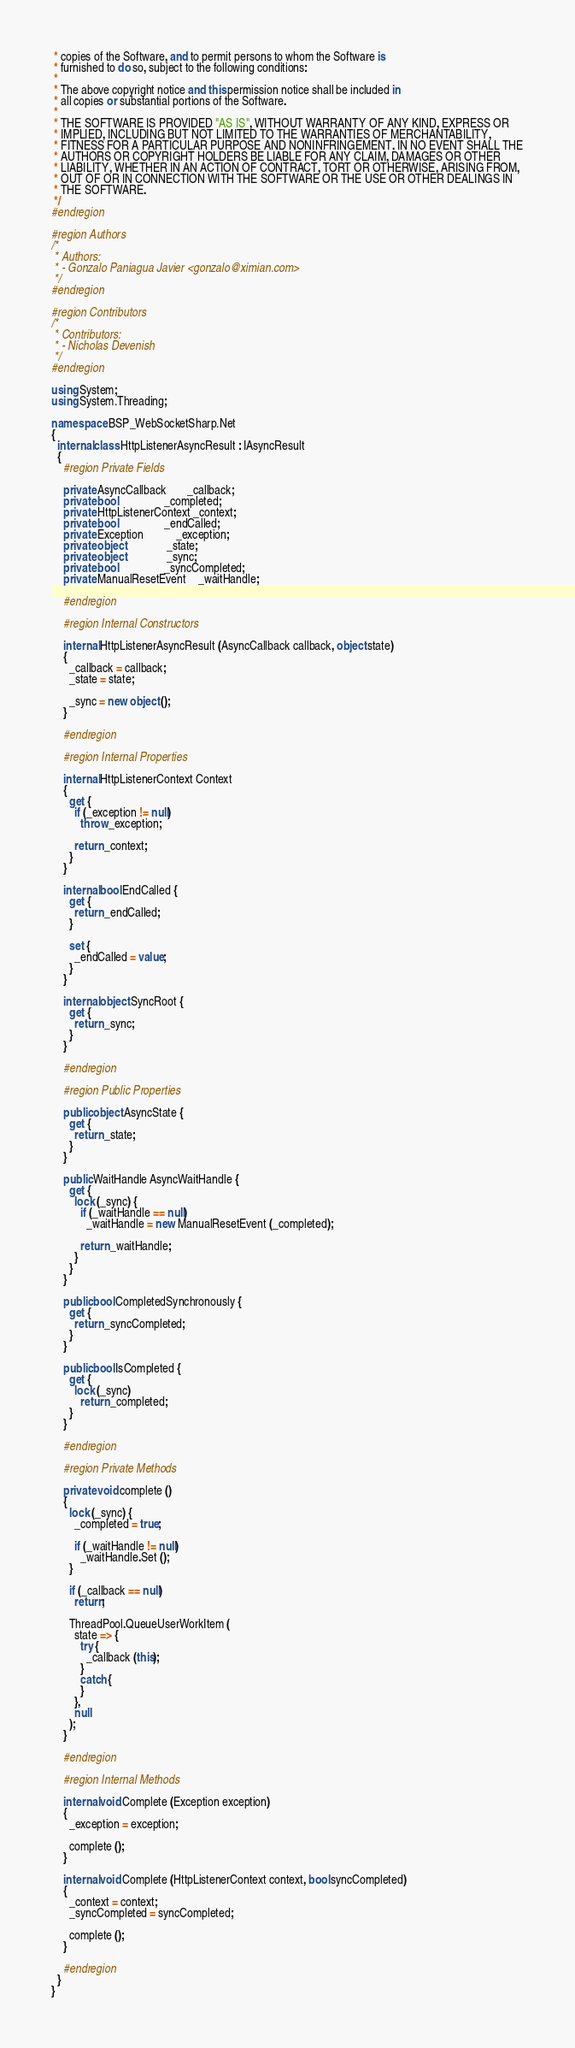<code> <loc_0><loc_0><loc_500><loc_500><_C#_> * copies of the Software, and to permit persons to whom the Software is
 * furnished to do so, subject to the following conditions:
 *
 * The above copyright notice and this permission notice shall be included in
 * all copies or substantial portions of the Software.
 *
 * THE SOFTWARE IS PROVIDED "AS IS", WITHOUT WARRANTY OF ANY KIND, EXPRESS OR
 * IMPLIED, INCLUDING BUT NOT LIMITED TO THE WARRANTIES OF MERCHANTABILITY,
 * FITNESS FOR A PARTICULAR PURPOSE AND NONINFRINGEMENT. IN NO EVENT SHALL THE
 * AUTHORS OR COPYRIGHT HOLDERS BE LIABLE FOR ANY CLAIM, DAMAGES OR OTHER
 * LIABILITY, WHETHER IN AN ACTION OF CONTRACT, TORT OR OTHERWISE, ARISING FROM,
 * OUT OF OR IN CONNECTION WITH THE SOFTWARE OR THE USE OR OTHER DEALINGS IN
 * THE SOFTWARE.
 */
#endregion

#region Authors
/*
 * Authors:
 * - Gonzalo Paniagua Javier <gonzalo@ximian.com>
 */
#endregion

#region Contributors
/*
 * Contributors:
 * - Nicholas Devenish
 */
#endregion

using System;
using System.Threading;

namespace BSP_WebSocketSharp.Net
{
  internal class HttpListenerAsyncResult : IAsyncResult
  {
    #region Private Fields

    private AsyncCallback       _callback;
    private bool                _completed;
    private HttpListenerContext _context;
    private bool                _endCalled;
    private Exception           _exception;
    private object              _state;
    private object              _sync;
    private bool                _syncCompleted;
    private ManualResetEvent    _waitHandle;

    #endregion

    #region Internal Constructors

    internal HttpListenerAsyncResult (AsyncCallback callback, object state)
    {
      _callback = callback;
      _state = state;

      _sync = new object ();
    }

    #endregion

    #region Internal Properties

    internal HttpListenerContext Context
    {
      get {
        if (_exception != null)
          throw _exception;

        return _context;
      }
    }

    internal bool EndCalled {
      get {
        return _endCalled;
      }

      set {
        _endCalled = value;
      }
    }

    internal object SyncRoot {
      get {
        return _sync;
      }
    }

    #endregion

    #region Public Properties

    public object AsyncState {
      get {
        return _state;
      }
    }

    public WaitHandle AsyncWaitHandle {
      get {
        lock (_sync) {
          if (_waitHandle == null)
            _waitHandle = new ManualResetEvent (_completed);

          return _waitHandle;
        }
      }
    }

    public bool CompletedSynchronously {
      get {
        return _syncCompleted;
      }
    }

    public bool IsCompleted {
      get {
        lock (_sync)
          return _completed;
      }
    }

    #endregion

    #region Private Methods

    private void complete ()
    {
      lock (_sync) {
        _completed = true;

        if (_waitHandle != null)
          _waitHandle.Set ();
      }

      if (_callback == null)
        return;

      ThreadPool.QueueUserWorkItem (
        state => {
          try {
            _callback (this);
          }
          catch {
          }
        },
        null
      );
    }

    #endregion

    #region Internal Methods

    internal void Complete (Exception exception)
    {
      _exception = exception;

      complete ();
    }

    internal void Complete (HttpListenerContext context, bool syncCompleted)
    {
      _context = context;
      _syncCompleted = syncCompleted;

      complete ();
    }

    #endregion
  }
}
</code> 